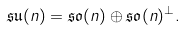Convert formula to latex. <formula><loc_0><loc_0><loc_500><loc_500>\mathfrak { s u } ( n ) = \mathfrak { s o } ( n ) \oplus \mathfrak { s o } ( n ) ^ { \perp } .</formula> 